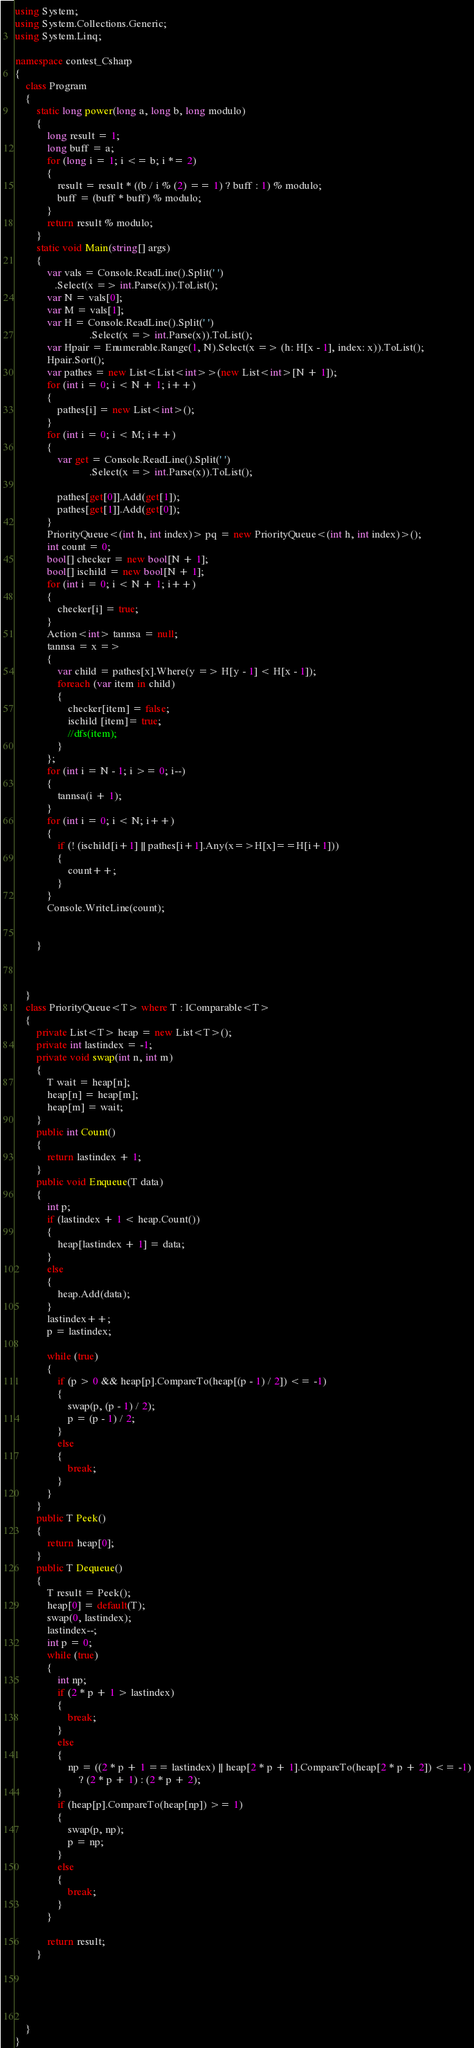Convert code to text. <code><loc_0><loc_0><loc_500><loc_500><_C#_>using System;
using System.Collections.Generic;
using System.Linq;

namespace contest_Csharp
{
    class Program
    {
        static long power(long a, long b, long modulo)
        {
            long result = 1;
            long buff = a;
            for (long i = 1; i <= b; i *= 2)
            {
                result = result * ((b / i % (2) == 1) ? buff : 1) % modulo;
                buff = (buff * buff) % modulo;
            }
            return result % modulo;
        }
        static void Main(string[] args)
        {
            var vals = Console.ReadLine().Split(' ')
               .Select(x => int.Parse(x)).ToList();
            var N = vals[0];
            var M = vals[1];
            var H = Console.ReadLine().Split(' ')
                            .Select(x => int.Parse(x)).ToList();
            var Hpair = Enumerable.Range(1, N).Select(x => (h: H[x - 1], index: x)).ToList();
            Hpair.Sort();
            var pathes = new List<List<int>>(new List<int>[N + 1]);
            for (int i = 0; i < N + 1; i++)
            {
                pathes[i] = new List<int>();
            }
            for (int i = 0; i < M; i++)
            {
                var get = Console.ReadLine().Split(' ')
                            .Select(x => int.Parse(x)).ToList();

                pathes[get[0]].Add(get[1]);
                pathes[get[1]].Add(get[0]);
            }
            PriorityQueue<(int h, int index)> pq = new PriorityQueue<(int h, int index)>();
            int count = 0;
            bool[] checker = new bool[N + 1];
            bool[] ischild = new bool[N + 1];
            for (int i = 0; i < N + 1; i++)
            {
                checker[i] = true;
            }
            Action<int> tannsa = null;
            tannsa = x =>
            {
                var child = pathes[x].Where(y => H[y - 1] < H[x - 1]);
                foreach (var item in child)
                {
                    checker[item] = false;
                    ischild [item]= true;
                    //dfs(item);
                }
            };
            for (int i = N - 1; i >= 0; i--)
            {
                tannsa(i + 1);
            }
            for (int i = 0; i < N; i++)
            {
                if (! (ischild[i+1] || pathes[i+1].Any(x=>H[x]==H[i+1]))
                {
                    count++;
                }
            }
            Console.WriteLine(count);


        }



    }
    class PriorityQueue<T> where T : IComparable<T>
    {
        private List<T> heap = new List<T>();
        private int lastindex = -1;
        private void swap(int n, int m)
        {
            T wait = heap[n];
            heap[n] = heap[m];
            heap[m] = wait;
        }
        public int Count()
        {
            return lastindex + 1;
        }
        public void Enqueue(T data)
        {
            int p;
            if (lastindex + 1 < heap.Count())
            {
                heap[lastindex + 1] = data;
            }
            else
            {
                heap.Add(data);
            }
            lastindex++;
            p = lastindex;

            while (true)
            {
                if (p > 0 && heap[p].CompareTo(heap[(p - 1) / 2]) <= -1)
                {
                    swap(p, (p - 1) / 2);
                    p = (p - 1) / 2;
                }
                else
                {
                    break;
                }
            }
        }
        public T Peek()
        {
            return heap[0];
        }
        public T Dequeue()
        {
            T result = Peek();
            heap[0] = default(T);
            swap(0, lastindex);
            lastindex--;
            int p = 0;
            while (true)
            {
                int np;
                if (2 * p + 1 > lastindex)
                {
                    break;
                }
                else
                {
                    np = ((2 * p + 1 == lastindex) || heap[2 * p + 1].CompareTo(heap[2 * p + 2]) <= -1)
                        ? (2 * p + 1) : (2 * p + 2);
                }
                if (heap[p].CompareTo(heap[np]) >= 1)
                {
                    swap(p, np);
                    p = np;
                }
                else
                {
                    break;
                }
            }

            return result;
        }





    }
}
</code> 